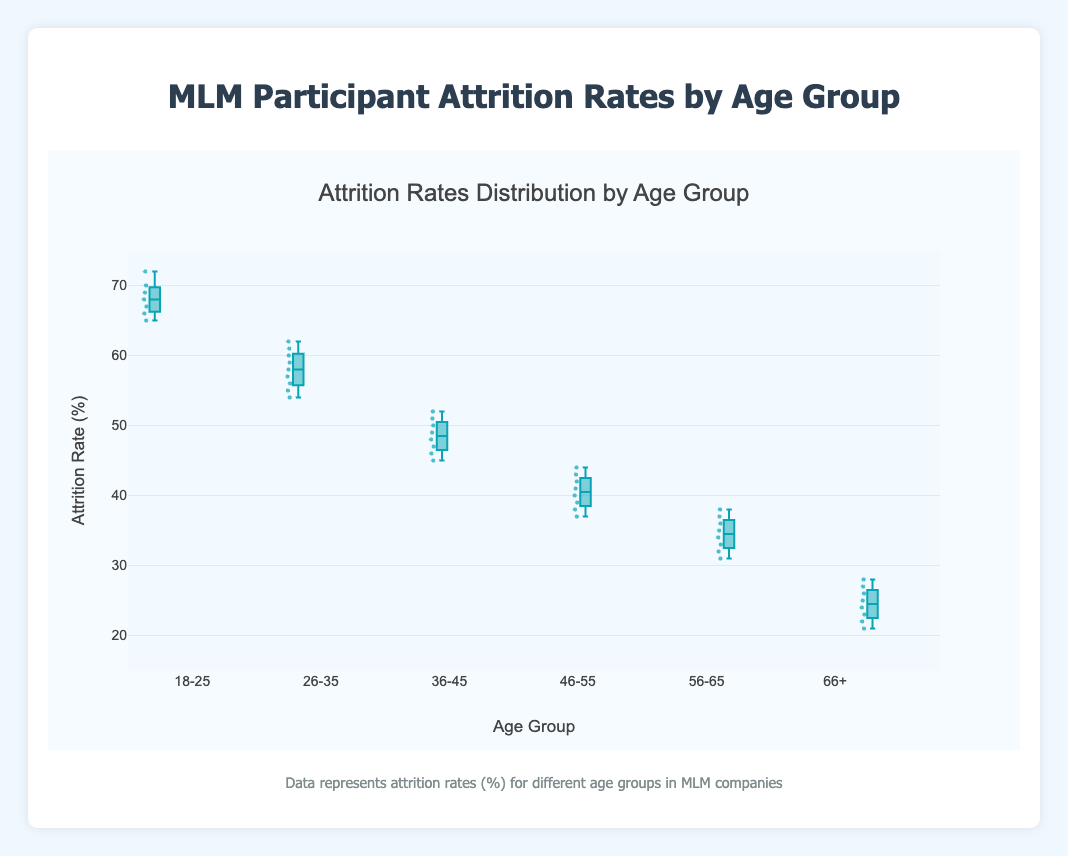What is the title of the plot? The title is usually located at the top of the plot and it summarizes the main subject being displayed.
Answer: Attrition Rates Distribution by Age Group Which age group has the lowest median attrition rate? The median is represented by the line in the middle of the box for each group, and the lowest median line is under "66+" group.
Answer: 66+ What is the y-axis title? The y-axis title is typically found along the vertical axis and describes what is being measured.
Answer: Attrition Rate (%) What is the range of attrition rates for the 18-25 age group? The range can be found by subtracting the minimum value of the whisker from the maximum value of the whisker for the 18-25 age group.
Answer: 66 to 72 What is the interquartile range (IQR) for the 26-35 age group? The IQR can be found by subtracting the 25th percentile (the bottom of the box) from the 75th percentile (the top of the box) for the 26-35 age group.
Answer: 54 to 60 Which age group has the widest range of attrition rates? The range of each group can be judged by examining the distance between the whiskers (ends of the lines) for each boxplot. The 18-25 age group shows the widest range.
Answer: 18-25 Which age group shows the most consistent (least spread) attrition rates? Consistency here can be interpreted by looking at the box and whiskers that are closest together, indicating less variation. The "66+ age group" has the least spread.
Answer: 66+ In which age group do the majority of data points lie within a smaller range? This can be identified by observing the height of the boxes (the interquartile range) for each group. The "66+ age group" has the smallest box, indicating a narrower range where most data points lie.
Answer: 66+ Which age group has an outlier in its attrition rates? Outliers in a box plot are typically shown as individual points outside the whiskers. The 26-35 age group has no evident outliers shown in the plot as separated points.
Answer: None 